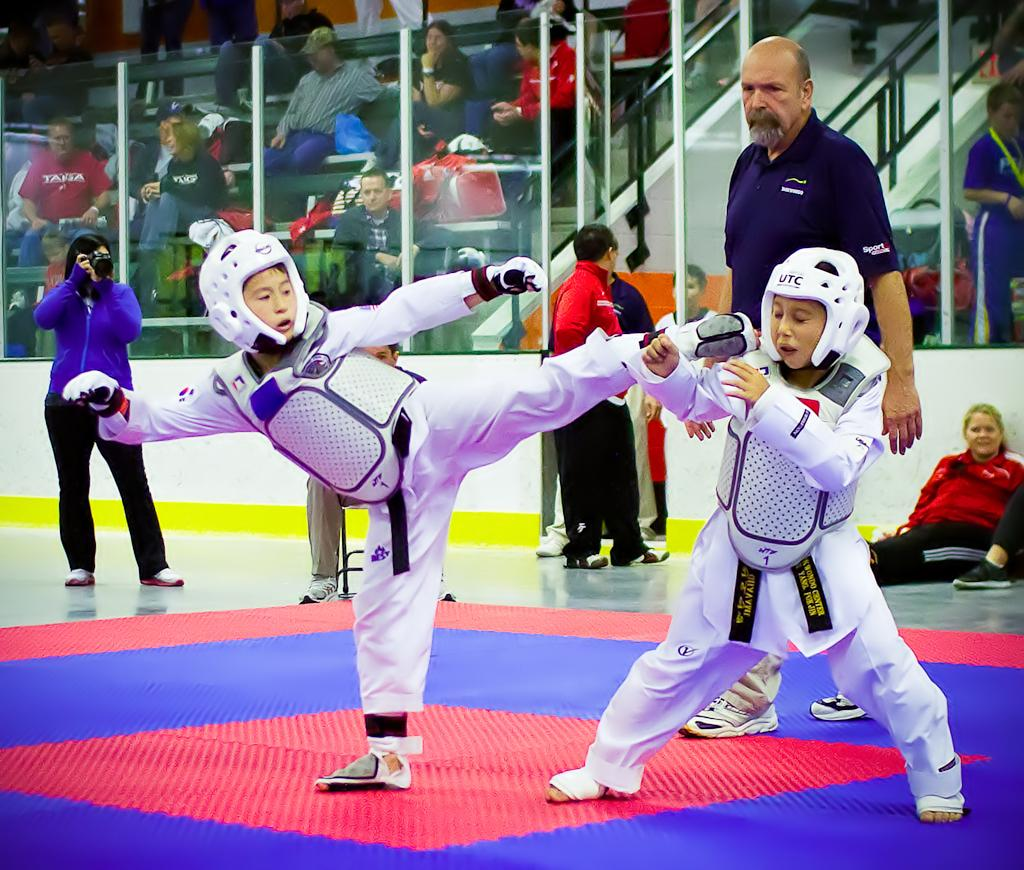What is the position of the persons in the image? The persons are on the floor. What can be seen in the background of the image? There are poles and persons sitting on chairs in the background. What type of truck is parked near the persons in the image? There is no truck present in the image. What work-related activity is being performed by the persons in the image? The image does not show any work-related activity being performed by the persons. 